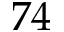Convert formula to latex. <formula><loc_0><loc_0><loc_500><loc_500>^ { 7 } 4</formula> 